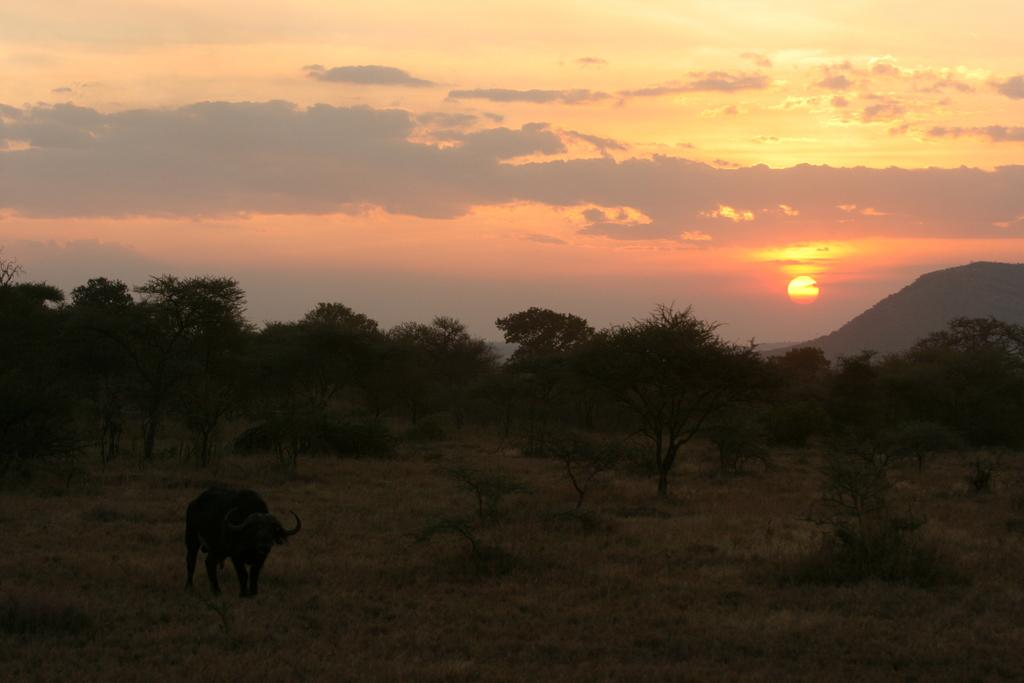What animal is the main subject of the image? There is a buffalo in the image. What is the buffalo standing on? The buffalo is on the surface of the grass. What can be seen in the distance behind the buffalo? There are trees, mountains, and the sky visible in the background of the image. What riddle does the buffalo solve in the image? There is no riddle present in the image, nor does the buffalo solve any riddles. 